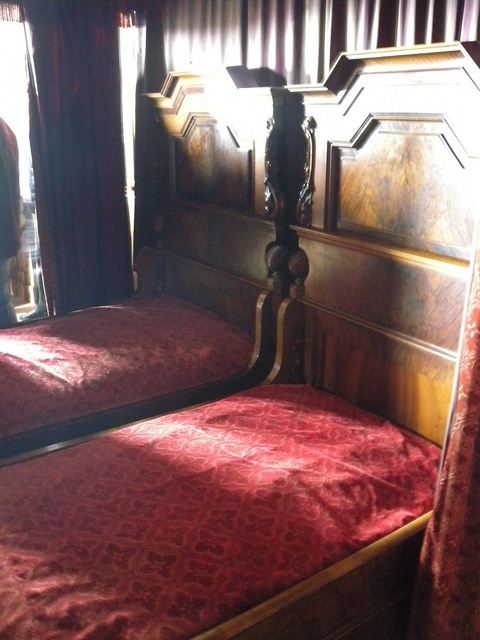Describe the objects in this image and their specific colors. I can see bed in gray, maroon, black, white, and brown tones, bed in gray, black, maroon, and white tones, and people in gray, blue, and darkgray tones in this image. 